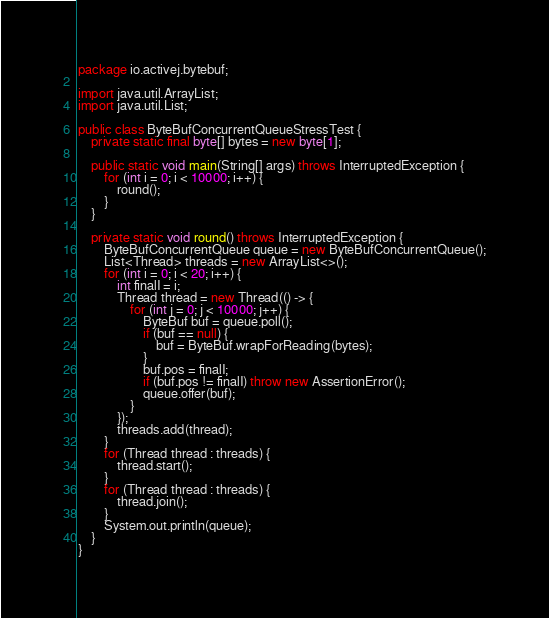Convert code to text. <code><loc_0><loc_0><loc_500><loc_500><_Java_>package io.activej.bytebuf;

import java.util.ArrayList;
import java.util.List;

public class ByteBufConcurrentQueueStressTest {
	private static final byte[] bytes = new byte[1];

	public static void main(String[] args) throws InterruptedException {
		for (int i = 0; i < 10000; i++) {
			round();
		}
	}

	private static void round() throws InterruptedException {
		ByteBufConcurrentQueue queue = new ByteBufConcurrentQueue();
		List<Thread> threads = new ArrayList<>();
		for (int i = 0; i < 20; i++) {
			int finalI = i;
			Thread thread = new Thread(() -> {
				for (int j = 0; j < 10000; j++) {
					ByteBuf buf = queue.poll();
					if (buf == null) {
						buf = ByteBuf.wrapForReading(bytes);
					}
					buf.pos = finalI;
					if (buf.pos != finalI) throw new AssertionError();
					queue.offer(buf);
				}
			});
			threads.add(thread);
		}
		for (Thread thread : threads) {
			thread.start();
		}
		for (Thread thread : threads) {
			thread.join();
		}
		System.out.println(queue);
	}
}
</code> 